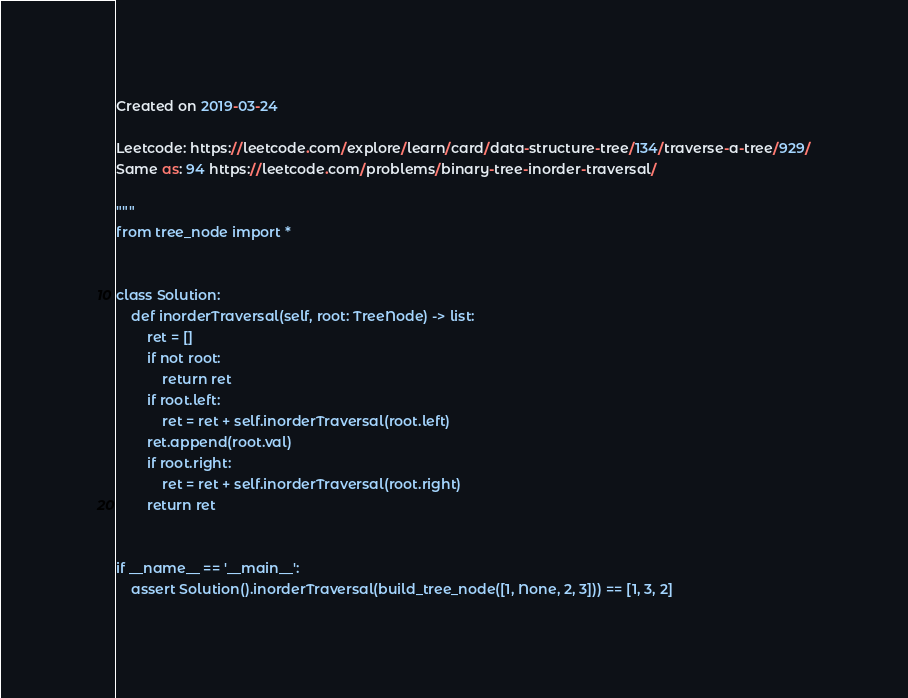<code> <loc_0><loc_0><loc_500><loc_500><_Python_>Created on 2019-03-24

Leetcode: https://leetcode.com/explore/learn/card/data-structure-tree/134/traverse-a-tree/929/
Same as: 94 https://leetcode.com/problems/binary-tree-inorder-traversal/

"""
from tree_node import *


class Solution:
    def inorderTraversal(self, root: TreeNode) -> list:
        ret = []
        if not root:
            return ret
        if root.left:
            ret = ret + self.inorderTraversal(root.left)
        ret.append(root.val)
        if root.right:
            ret = ret + self.inorderTraversal(root.right)
        return ret


if __name__ == '__main__':
    assert Solution().inorderTraversal(build_tree_node([1, None, 2, 3])) == [1, 3, 2]
</code> 